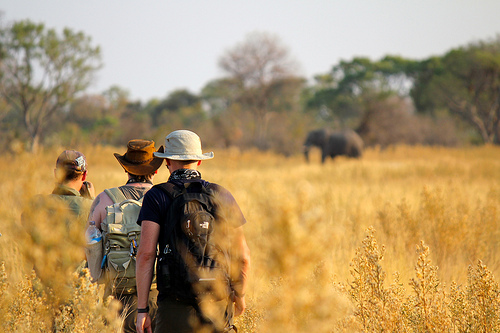Is the animal that is standing large and gray? Yes, the standing animal is large and gray. 